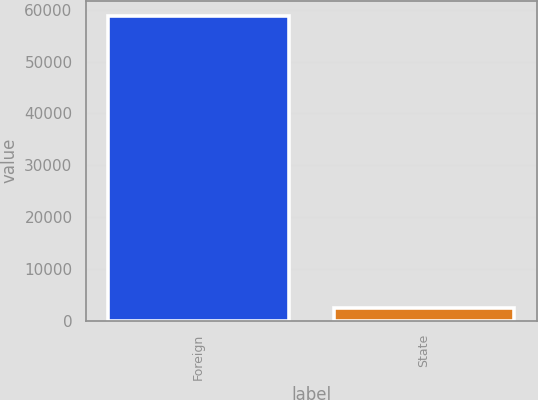Convert chart. <chart><loc_0><loc_0><loc_500><loc_500><bar_chart><fcel>Foreign<fcel>State<nl><fcel>58785<fcel>2435<nl></chart> 